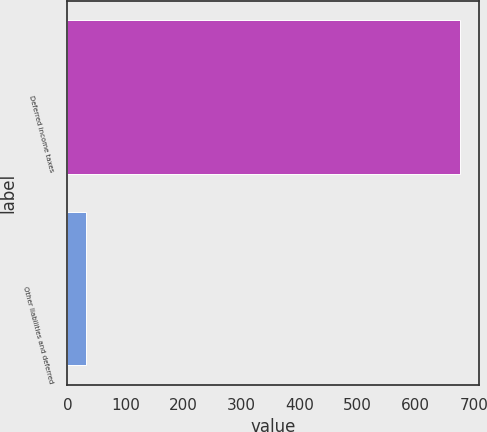Convert chart. <chart><loc_0><loc_0><loc_500><loc_500><bar_chart><fcel>Deferred income taxes<fcel>Other liabilities and deferred<nl><fcel>676<fcel>32<nl></chart> 